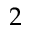Convert formula to latex. <formula><loc_0><loc_0><loc_500><loc_500>2</formula> 